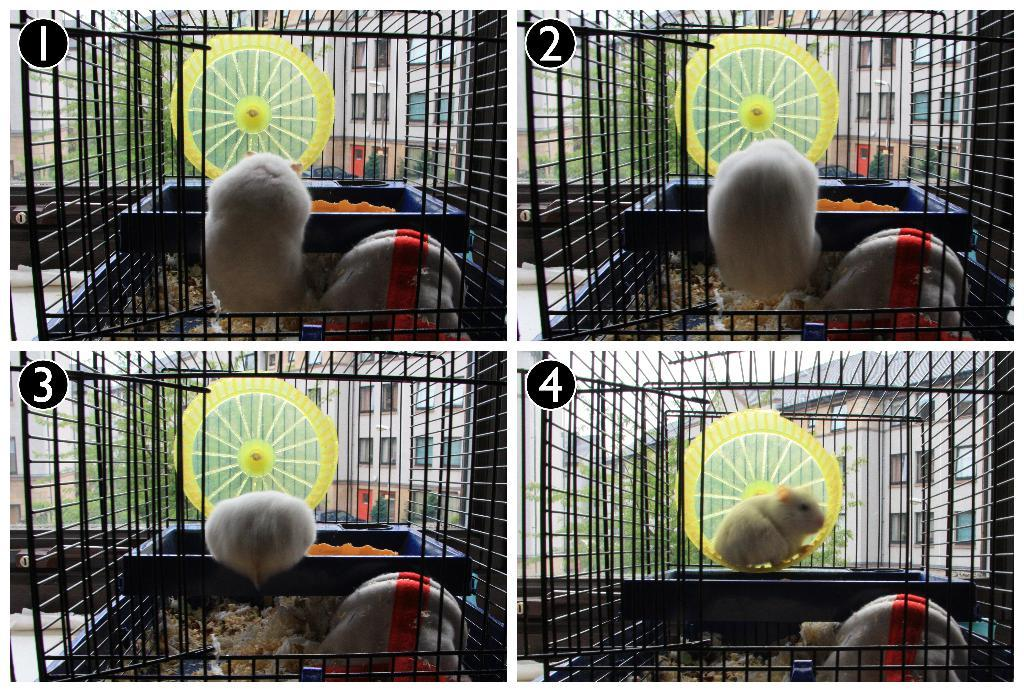What animal is present in the image? There is a mouse in the image. What is the mouse contained within? The mouse is in a cage in the image. What is the mouse likely to eat in the image? There is food in the image, which the mouse might eat. What type of structures can be seen in the image? There are buildings in the image. What type of vegetation is present in the image? There is a tree in the image. How does the mouse vest control the buildings in the image? There is no mention of a mouse vest or any control over the buildings in the image. The image only shows a mouse in a cage with food, a tree, and buildings in the background. 